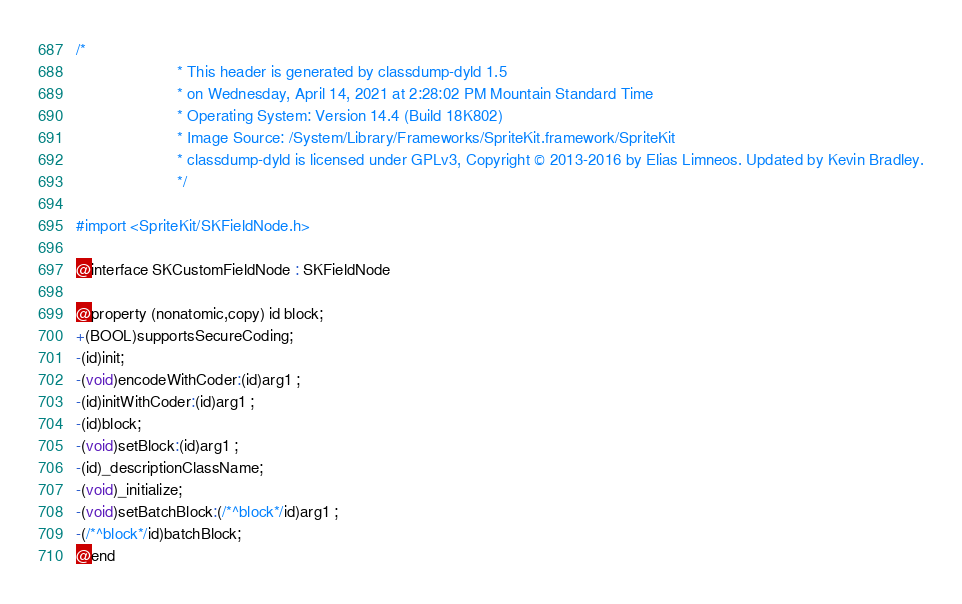<code> <loc_0><loc_0><loc_500><loc_500><_C_>/*
                       * This header is generated by classdump-dyld 1.5
                       * on Wednesday, April 14, 2021 at 2:28:02 PM Mountain Standard Time
                       * Operating System: Version 14.4 (Build 18K802)
                       * Image Source: /System/Library/Frameworks/SpriteKit.framework/SpriteKit
                       * classdump-dyld is licensed under GPLv3, Copyright © 2013-2016 by Elias Limneos. Updated by Kevin Bradley.
                       */

#import <SpriteKit/SKFieldNode.h>

@interface SKCustomFieldNode : SKFieldNode

@property (nonatomic,copy) id block; 
+(BOOL)supportsSecureCoding;
-(id)init;
-(void)encodeWithCoder:(id)arg1 ;
-(id)initWithCoder:(id)arg1 ;
-(id)block;
-(void)setBlock:(id)arg1 ;
-(id)_descriptionClassName;
-(void)_initialize;
-(void)setBatchBlock:(/*^block*/id)arg1 ;
-(/*^block*/id)batchBlock;
@end

</code> 